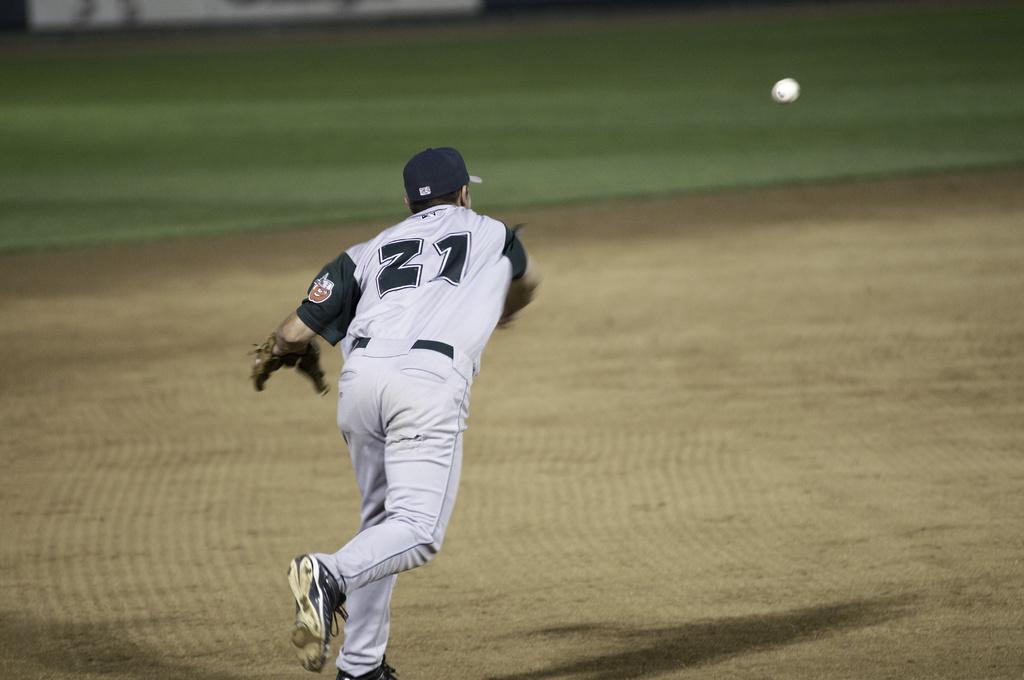What player number is featured?
Ensure brevity in your answer.  21. 